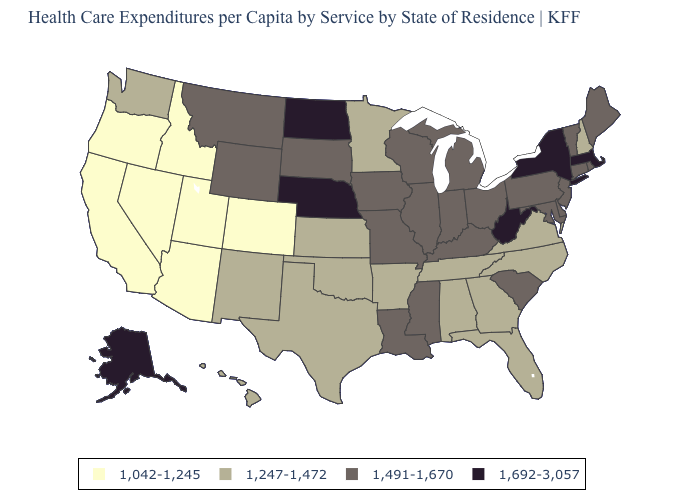Which states have the highest value in the USA?
Answer briefly. Alaska, Massachusetts, Nebraska, New York, North Dakota, West Virginia. Which states hav the highest value in the West?
Short answer required. Alaska. What is the value of New Mexico?
Answer briefly. 1,247-1,472. Name the states that have a value in the range 1,692-3,057?
Answer briefly. Alaska, Massachusetts, Nebraska, New York, North Dakota, West Virginia. Does Oregon have the highest value in the West?
Give a very brief answer. No. Which states have the highest value in the USA?
Be succinct. Alaska, Massachusetts, Nebraska, New York, North Dakota, West Virginia. What is the value of Nevada?
Give a very brief answer. 1,042-1,245. What is the lowest value in states that border New Hampshire?
Concise answer only. 1,491-1,670. Name the states that have a value in the range 1,491-1,670?
Concise answer only. Connecticut, Delaware, Illinois, Indiana, Iowa, Kentucky, Louisiana, Maine, Maryland, Michigan, Mississippi, Missouri, Montana, New Jersey, Ohio, Pennsylvania, Rhode Island, South Carolina, South Dakota, Vermont, Wisconsin, Wyoming. Does the first symbol in the legend represent the smallest category?
Write a very short answer. Yes. Does Alaska have the highest value in the West?
Short answer required. Yes. What is the highest value in the USA?
Short answer required. 1,692-3,057. Which states have the lowest value in the USA?
Give a very brief answer. Arizona, California, Colorado, Idaho, Nevada, Oregon, Utah. Name the states that have a value in the range 1,247-1,472?
Short answer required. Alabama, Arkansas, Florida, Georgia, Hawaii, Kansas, Minnesota, New Hampshire, New Mexico, North Carolina, Oklahoma, Tennessee, Texas, Virginia, Washington. What is the value of Hawaii?
Give a very brief answer. 1,247-1,472. 